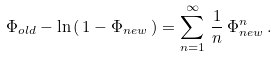Convert formula to latex. <formula><loc_0><loc_0><loc_500><loc_500>\Phi _ { o l d } - \ln \, ( \, 1 - \Phi _ { n e w } \, ) = \sum _ { n = 1 } ^ { \infty } \, \frac { 1 } { n } \, \Phi _ { n e w } ^ { n } \, .</formula> 